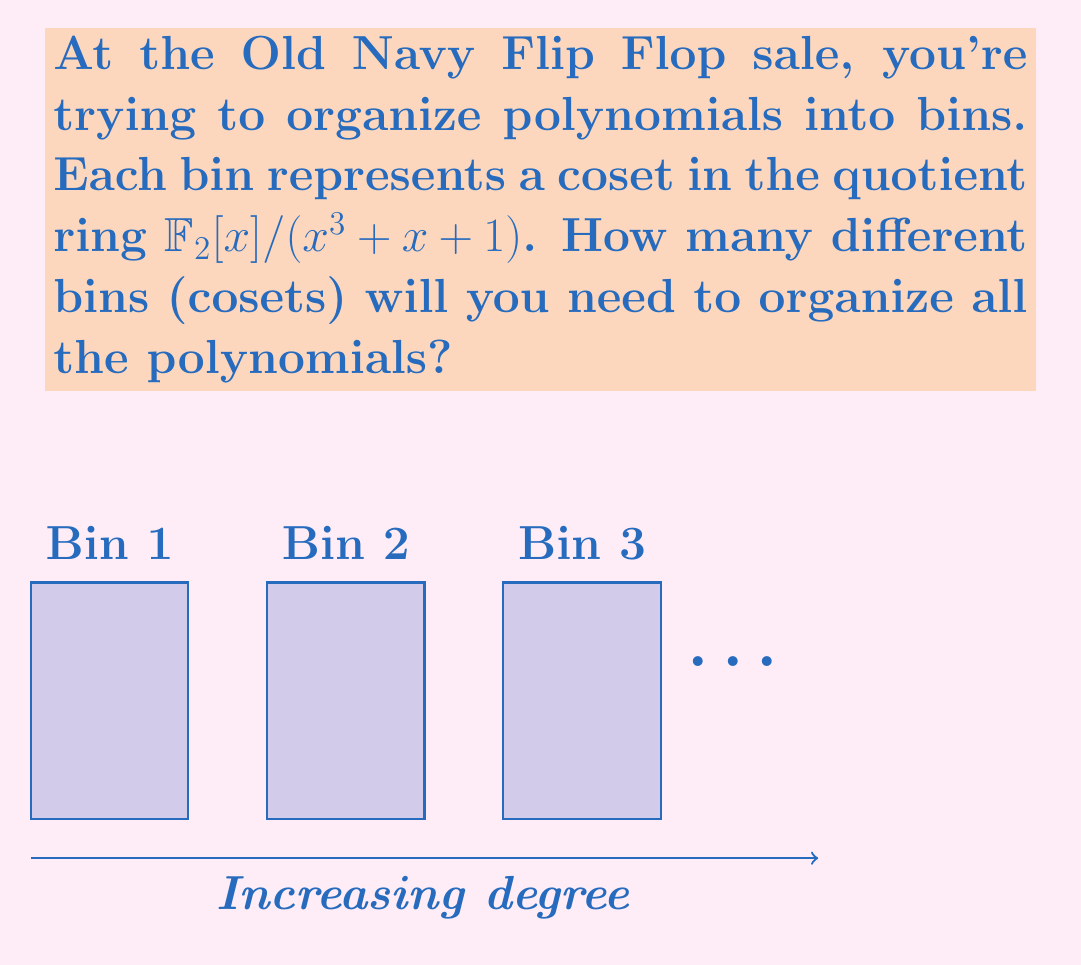Teach me how to tackle this problem. Let's approach this step-by-step:

1) The quotient ring we're dealing with is $\mathbb{F}_2[x]/(x^3 + x + 1)$.

2) In a quotient ring $R/I$, the number of elements (cosets) is equal to the number of elements in a complete set of residues modulo the ideal $I$.

3) In this case, $I$ is the ideal generated by the polynomial $x^3 + x + 1$ over $\mathbb{F}_2$.

4) The number of elements in the quotient ring is equal to the number of polynomials of degree less than the degree of $x^3 + x + 1$.

5) The degree of $x^3 + x + 1$ is 3.

6) So, we need to count the number of polynomials over $\mathbb{F}_2$ of degree less than 3.

7) These polynomials have the form $ax^2 + bx + c$, where $a, b, c \in \mathbb{F}_2 = \{0, 1\}$.

8) For each of $a, b,$ and $c$, we have 2 choices (0 or 1).

9) By the multiplication principle, the total number of such polynomials is $2 \times 2 \times 2 = 2^3 = 8$.

Therefore, the quotient ring $\mathbb{F}_2[x]/(x^3 + x + 1)$ has 8 elements, so you'll need 8 bins to organize all the polynomials.
Answer: 8 